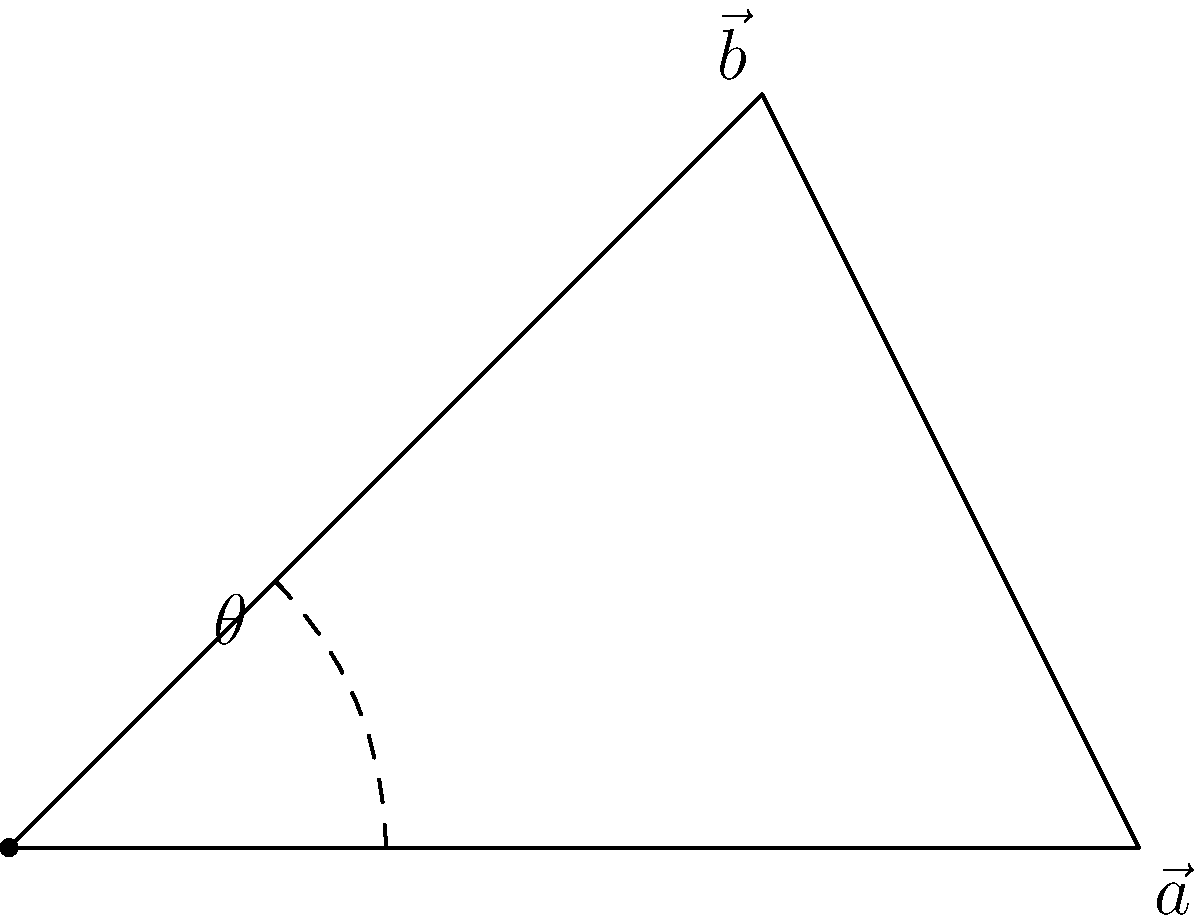Given two vectors $\vec{a} = (3, 0)$ and $\vec{b} = (2, 2)$, calculate their dot product and determine the angle $\theta$ between them. How would you visualize this angle using Python with a library that provides C++ bindings for vector operations and plotting? To solve this problem, we'll follow these steps:

1. Calculate the dot product of $\vec{a}$ and $\vec{b}$:
   $$\vec{a} \cdot \vec{b} = a_x b_x + a_y b_y = (3 \cdot 2) + (0 \cdot 2) = 6$$

2. Calculate the magnitudes of $\vec{a}$ and $\vec{b}$:
   $$|\vec{a}| = \sqrt{3^2 + 0^2} = 3$$
   $$|\vec{b}| = \sqrt{2^2 + 2^2} = 2\sqrt{2}$$

3. Use the dot product formula to find $\cos \theta$:
   $$\cos \theta = \frac{\vec{a} \cdot \vec{b}}{|\vec{a}||\vec{b}|} = \frac{6}{3 \cdot 2\sqrt{2}} = \frac{\sqrt{2}}{2}$$

4. Calculate $\theta$ using the inverse cosine function:
   $$\theta = \arccos(\frac{\sqrt{2}}{2}) \approx 0.7854 \text{ radians} \approx 45°$$

To visualize this using Python with C++ bindings:

1. Use a library like pybind11 to create Python bindings for C++ vector operations.
2. Implement vector operations (dot product, magnitude) in C++.
3. Use a plotting library with C++ backends, such as matplotlib-cpp, to create the visualization.
4. In Python, use the bound C++ functions to perform calculations and the plotting library to draw the vectors and the angle between them.

Example Python code (assuming C++ bindings are set up):

```python
import vector_ops  # C++ bindings
import plot_lib    # C++ based plotting library

a = vector_ops.Vector2D(3, 0)
b = vector_ops.Vector2D(2, 2)

dot_product = vector_ops.dot(a, b)
angle = vector_ops.angle_between(a, b)

plot = plot_lib.Plot()
plot.add_vector(a)
plot.add_vector(b)
plot.add_angle(angle)
plot.show()
```

This approach leverages C++ performance for computations while providing a Python interface for ease of use.
Answer: Dot product: 6; Angle: 45°; Visualization: Use C++ vector operations via Python bindings and a C++-based plotting library. 